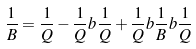<formula> <loc_0><loc_0><loc_500><loc_500>\frac { 1 } { B } = \frac { 1 } { Q } - \frac { 1 } { Q } b \frac { 1 } { Q } + \frac { 1 } { Q } b \frac { 1 } { B } b \frac { 1 } { Q }</formula> 